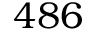Convert formula to latex. <formula><loc_0><loc_0><loc_500><loc_500>4 8 6</formula> 